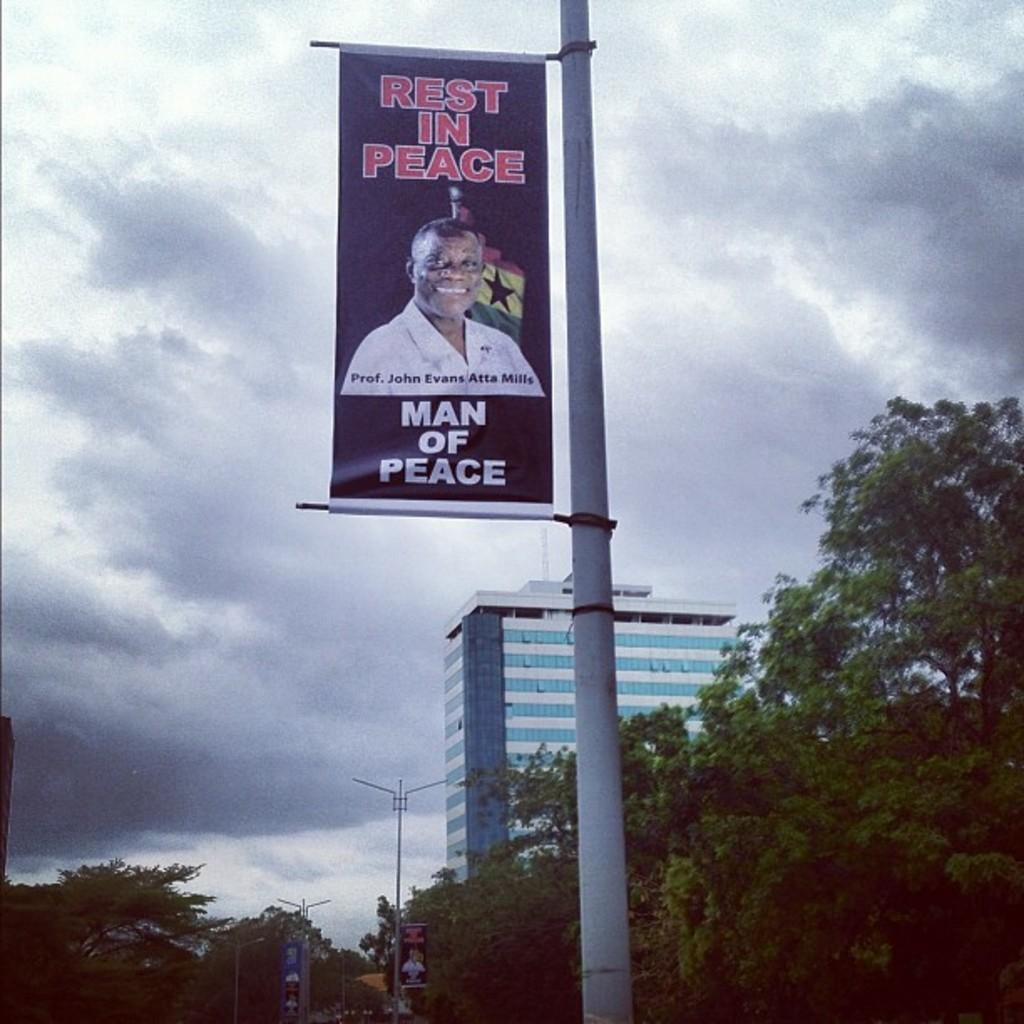<image>
Create a compact narrative representing the image presented. A poster that says rest in peace, man of peace 